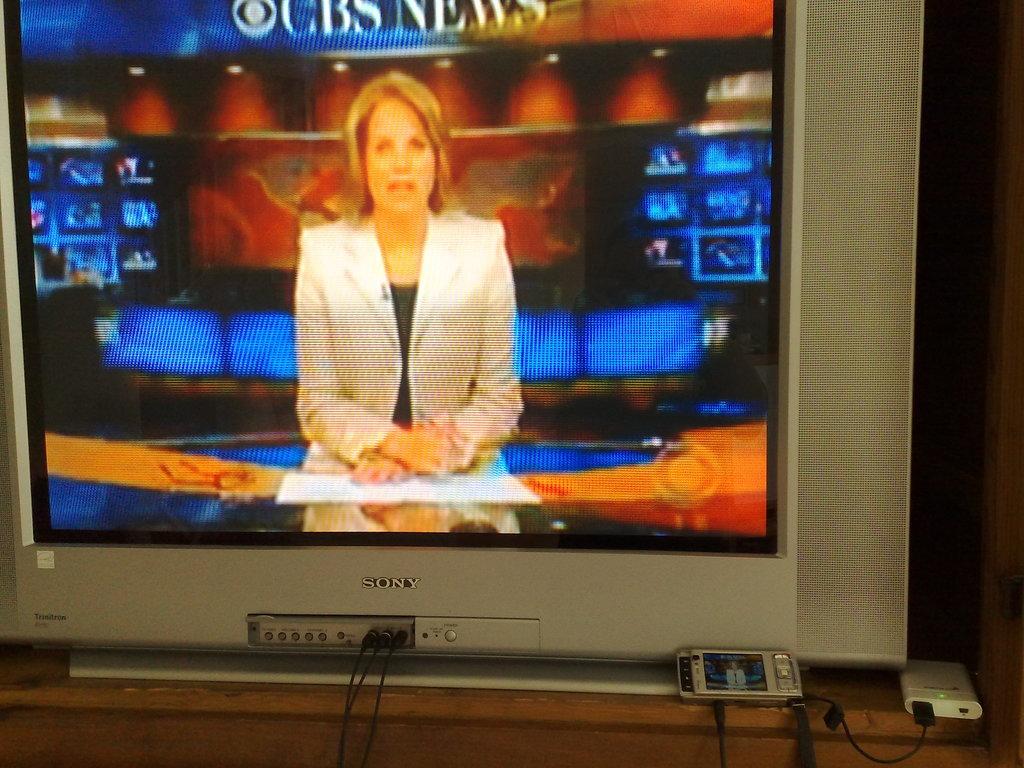What news station is on the television?
Give a very brief answer. Cbs. 